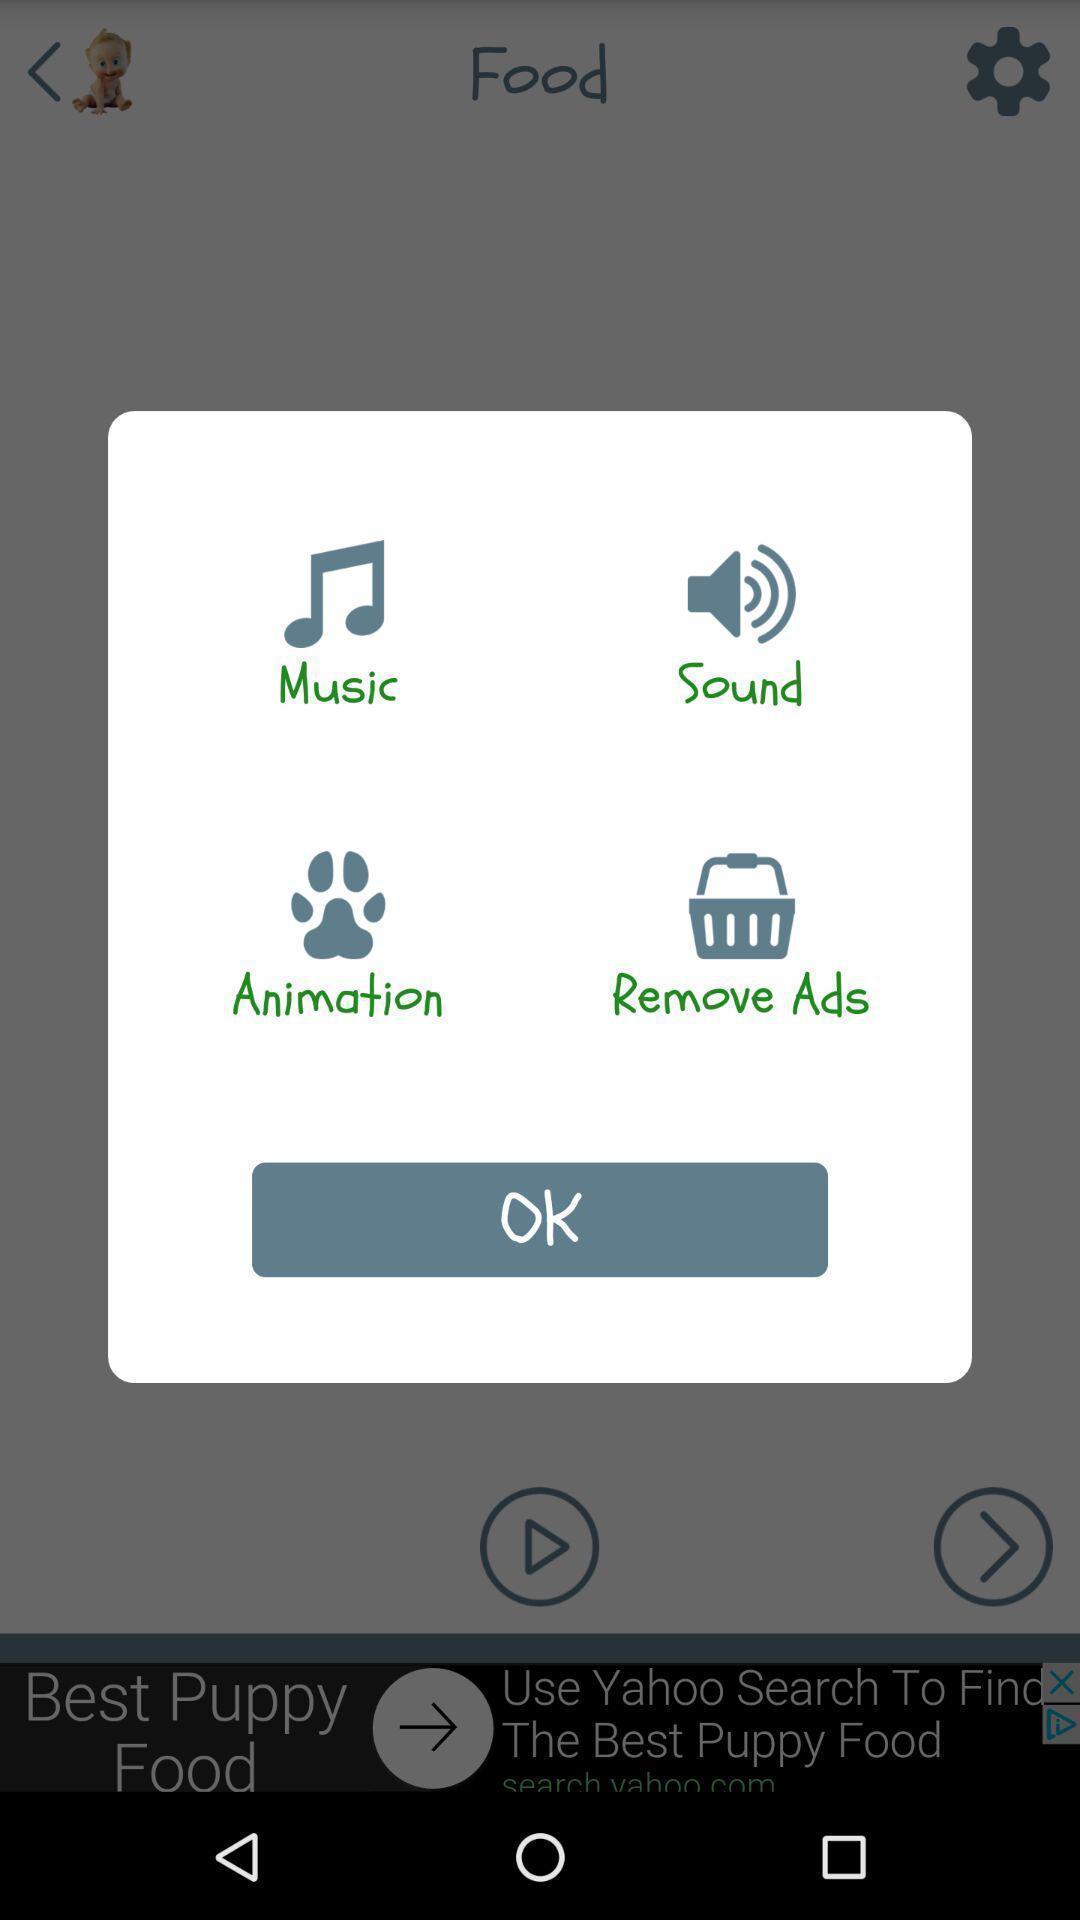Explain what's happening in this screen capture. Popup of the various applications to select. 